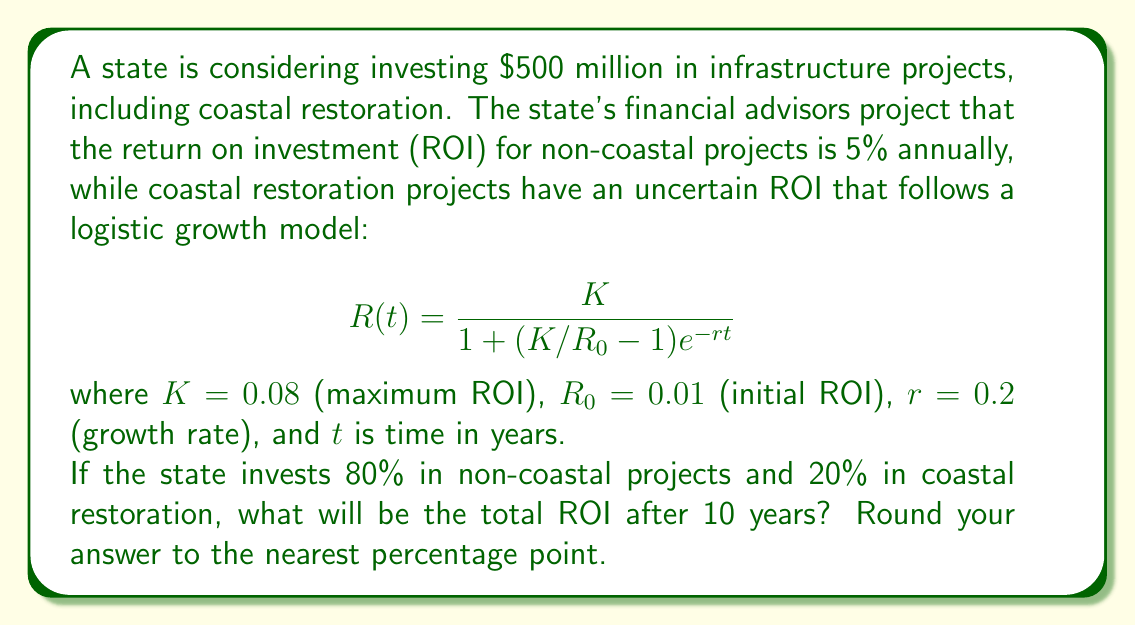Can you answer this question? Let's approach this step-by-step:

1) First, we need to calculate the ROI for non-coastal projects:
   80% of $500 million = $400 million
   ROI after 10 years = $400 million * (1 + 0.05)^10 = $651.56 million
   Profit = $651.56 million - $400 million = $251.56 million

2) For coastal restoration projects:
   20% of $500 million = $100 million
   We need to calculate R(10) using the logistic growth model:

   $$R(10) = \frac{0.08}{1 + (0.08/0.01 - 1)e^{-0.2*10}}$$

   $$R(10) = \frac{0.08}{1 + 7e^{-2}} \approx 0.0799$$

   This means the ROI for coastal projects after 10 years is approximately 7.99%

3) Profit from coastal projects:
   $100 million * 0.0799 * 10 = $79.9 million

4) Total profit:
   $251.56 million + $79.9 million = $331.46 million

5) Total ROI:
   ($331.46 million / $500 million) * 100 = 66.292%

Rounding to the nearest percentage point gives 66%.
Answer: 66% 